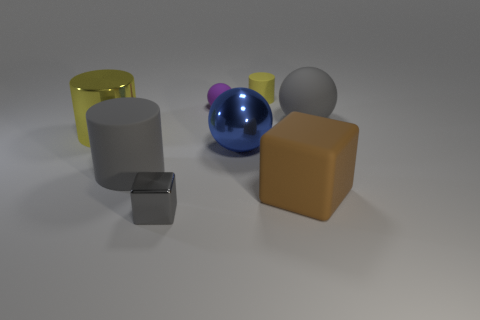Add 2 yellow objects. How many objects exist? 10 Subtract all yellow cylinders. How many cylinders are left? 1 Subtract all big spheres. How many spheres are left? 1 Subtract all blocks. How many objects are left? 6 Subtract 1 cubes. How many cubes are left? 1 Subtract all blue balls. How many cyan blocks are left? 0 Subtract all brown rubber things. Subtract all gray metal blocks. How many objects are left? 6 Add 1 tiny yellow cylinders. How many tiny yellow cylinders are left? 2 Add 7 big gray blocks. How many big gray blocks exist? 7 Subtract 1 purple balls. How many objects are left? 7 